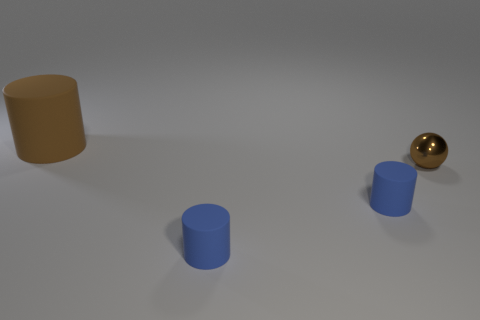Are the brown object that is behind the small brown object and the small ball made of the same material?
Give a very brief answer. No. How many objects are either big purple rubber blocks or brown things right of the big brown cylinder?
Provide a short and direct response. 1. What number of tiny blue objects have the same material as the large brown cylinder?
Provide a succinct answer. 2. How many brown cylinders are there?
Your response must be concise. 1. What number of things are to the right of the big rubber cylinder?
Provide a succinct answer. 3. There is a big object that is the same color as the metal sphere; what is it made of?
Provide a succinct answer. Rubber. Are there any other things that have the same shape as the small brown shiny thing?
Your answer should be compact. No. Do the thing behind the tiny shiny object and the brown thing that is right of the brown cylinder have the same material?
Offer a very short reply. No. What size is the brown object in front of the brown thing behind the brown thing that is right of the big brown object?
Ensure brevity in your answer.  Small. Are there any other spheres that have the same size as the brown sphere?
Your answer should be compact. No. 